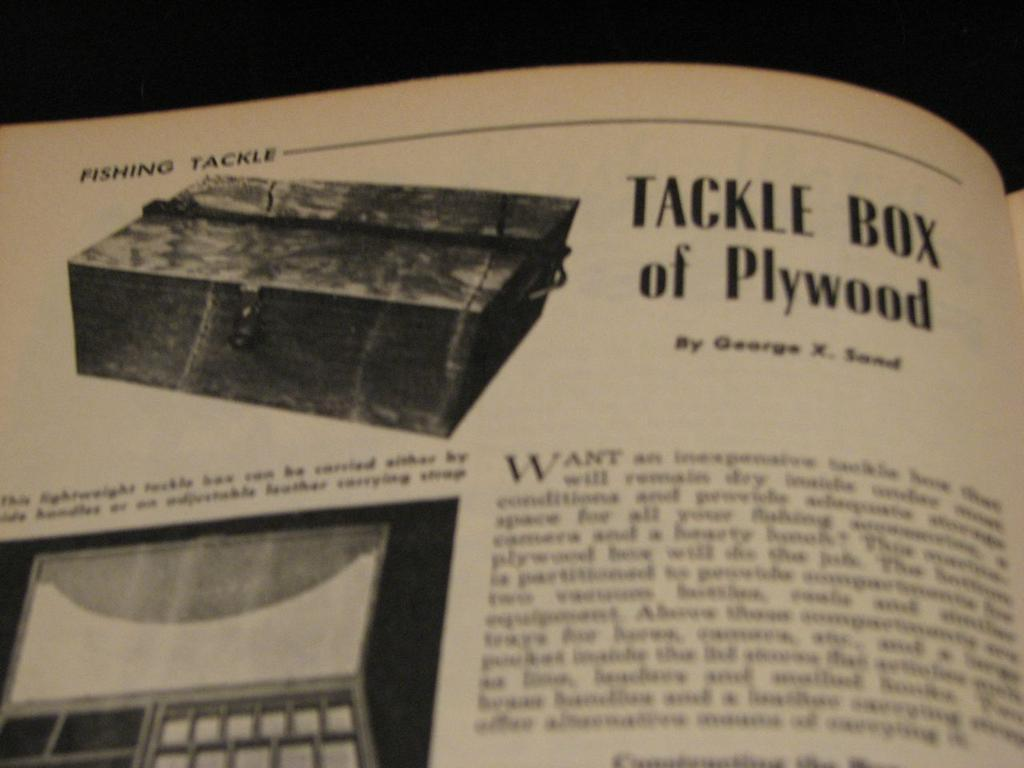<image>
Provide a brief description of the given image. a page in a book titled Tackle Box of Plywood 